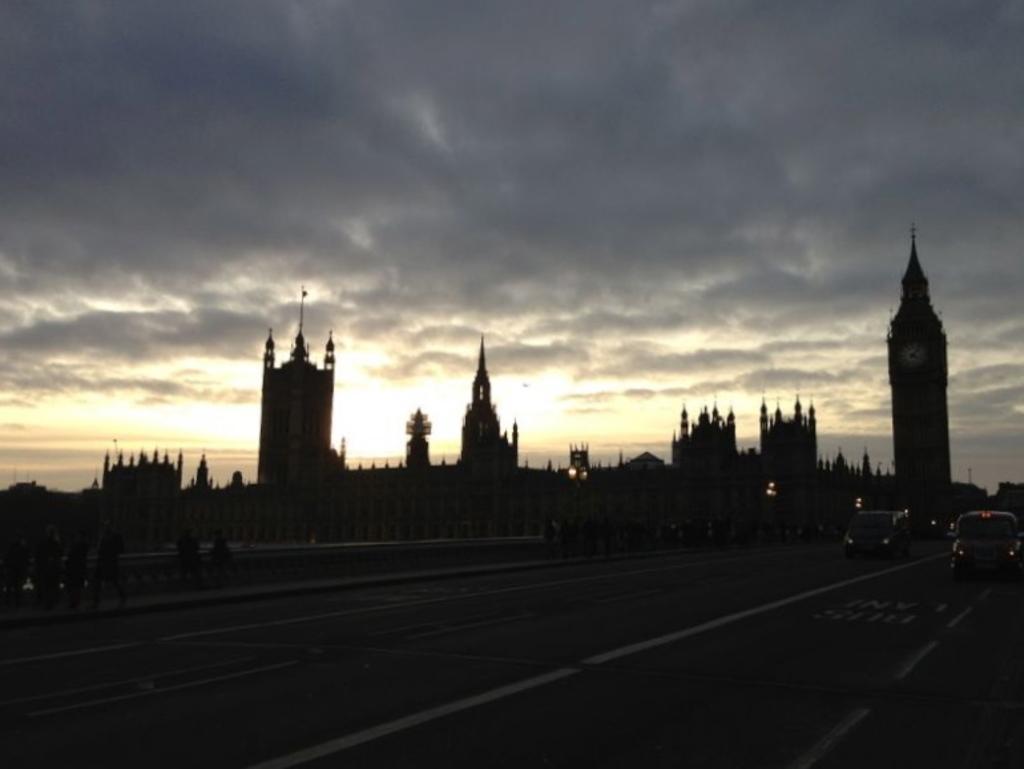Describe this image in one or two sentences. In this image we can see the vehicles on the road, there are some buildings and people, in the background, we can see the sky with clouds. 